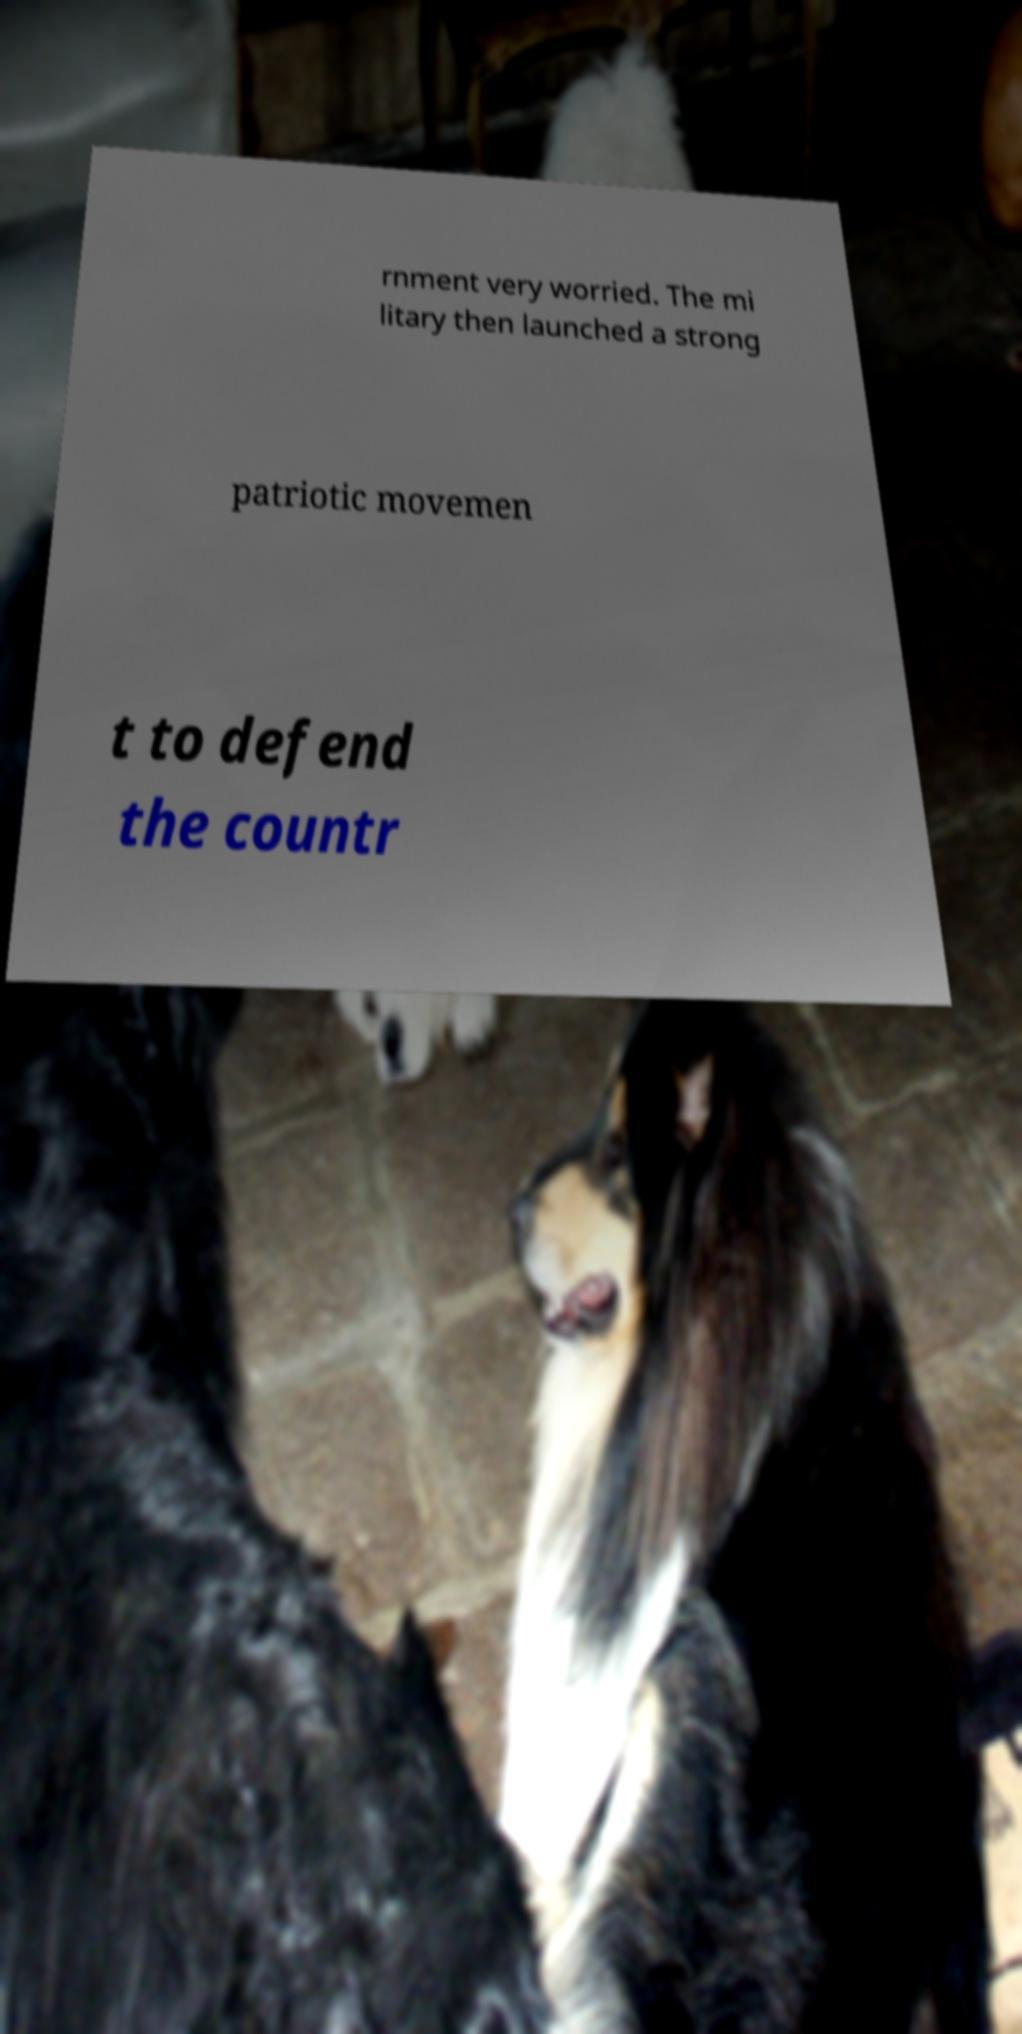Can you accurately transcribe the text from the provided image for me? rnment very worried. The mi litary then launched a strong patriotic movemen t to defend the countr 